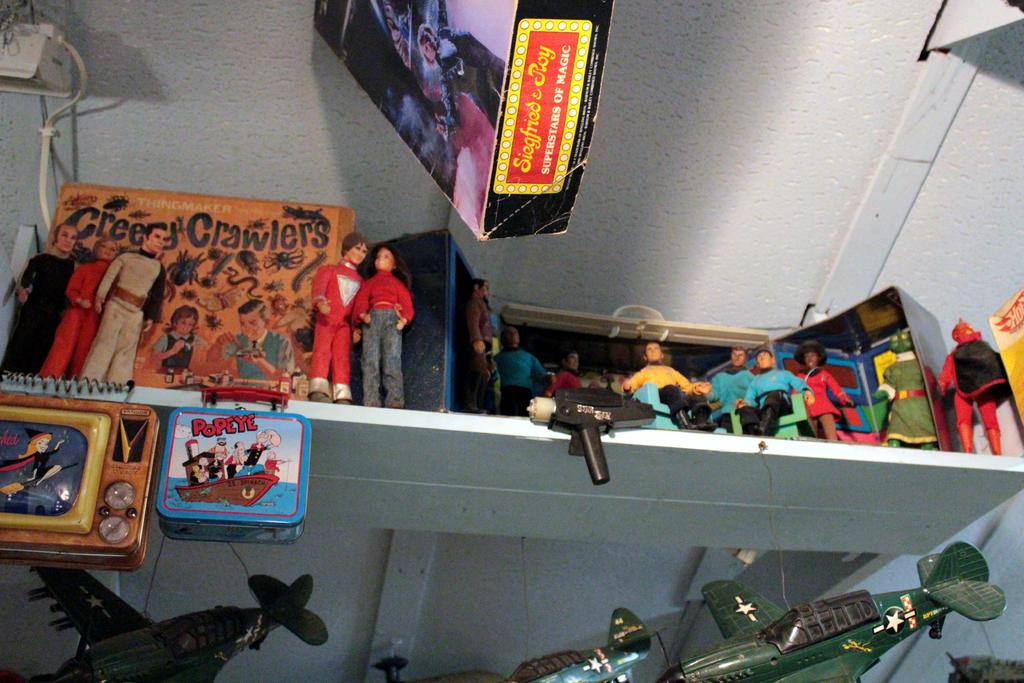What type of objects can be seen in the image? There are toys and boxes in the image. Can you describe any other elements in the image? Yes, there is a cable visible in the image. What might be used for organizing or storing items in the image? There is a rack in the image for organizing or storing items. What type of wine is being served during the afterthought in the image? There is no mention of an afterthought or wine in the image; it only features toys, boxes, a cable, and a rack. 